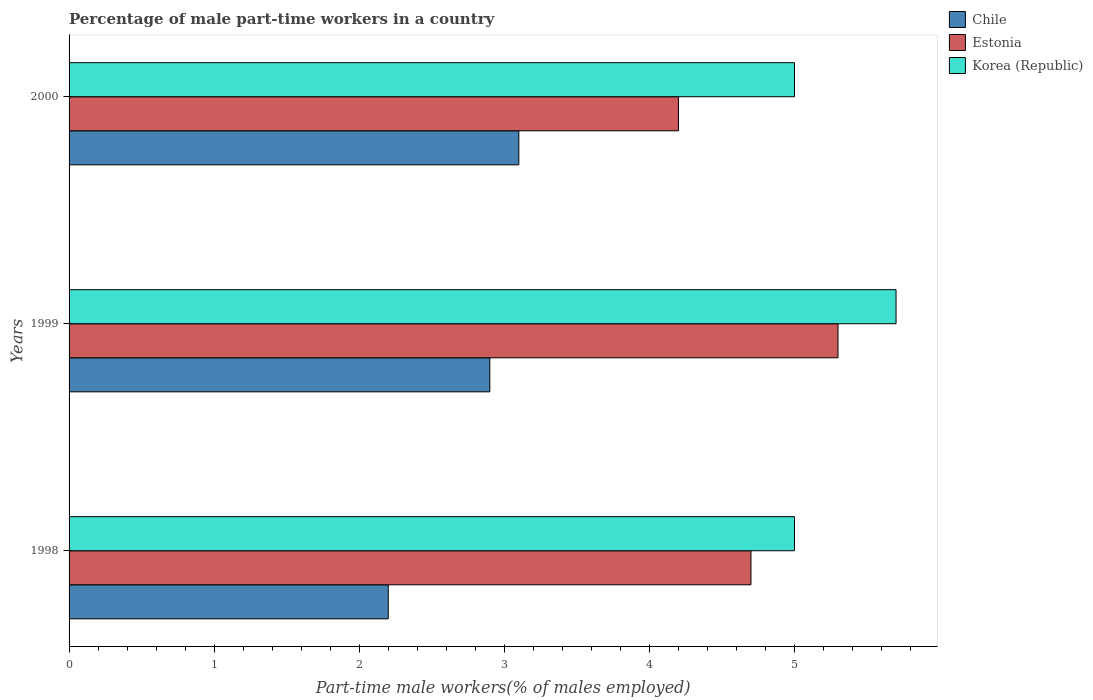Are the number of bars per tick equal to the number of legend labels?
Provide a short and direct response. Yes. Are the number of bars on each tick of the Y-axis equal?
Offer a terse response. Yes. What is the label of the 1st group of bars from the top?
Provide a short and direct response. 2000. What is the percentage of male part-time workers in Estonia in 1999?
Make the answer very short. 5.3. Across all years, what is the maximum percentage of male part-time workers in Chile?
Provide a short and direct response. 3.1. In which year was the percentage of male part-time workers in Estonia maximum?
Provide a succinct answer. 1999. What is the total percentage of male part-time workers in Estonia in the graph?
Keep it short and to the point. 14.2. What is the difference between the percentage of male part-time workers in Estonia in 2000 and the percentage of male part-time workers in Korea (Republic) in 1999?
Your answer should be very brief. -1.5. What is the average percentage of male part-time workers in Estonia per year?
Provide a succinct answer. 4.73. In the year 1998, what is the difference between the percentage of male part-time workers in Estonia and percentage of male part-time workers in Korea (Republic)?
Your answer should be compact. -0.3. What is the ratio of the percentage of male part-time workers in Chile in 1998 to that in 1999?
Provide a short and direct response. 0.76. Is the difference between the percentage of male part-time workers in Estonia in 1998 and 1999 greater than the difference between the percentage of male part-time workers in Korea (Republic) in 1998 and 1999?
Provide a short and direct response. Yes. What is the difference between the highest and the second highest percentage of male part-time workers in Estonia?
Ensure brevity in your answer.  0.6. What is the difference between the highest and the lowest percentage of male part-time workers in Korea (Republic)?
Ensure brevity in your answer.  0.7. In how many years, is the percentage of male part-time workers in Korea (Republic) greater than the average percentage of male part-time workers in Korea (Republic) taken over all years?
Give a very brief answer. 1. Is the sum of the percentage of male part-time workers in Estonia in 1999 and 2000 greater than the maximum percentage of male part-time workers in Korea (Republic) across all years?
Provide a succinct answer. Yes. What does the 2nd bar from the top in 1998 represents?
Offer a terse response. Estonia. What does the 2nd bar from the bottom in 1998 represents?
Ensure brevity in your answer.  Estonia. Is it the case that in every year, the sum of the percentage of male part-time workers in Korea (Republic) and percentage of male part-time workers in Estonia is greater than the percentage of male part-time workers in Chile?
Your answer should be very brief. Yes. How many bars are there?
Give a very brief answer. 9. What is the difference between two consecutive major ticks on the X-axis?
Your answer should be compact. 1. Are the values on the major ticks of X-axis written in scientific E-notation?
Provide a succinct answer. No. Does the graph contain grids?
Offer a very short reply. No. Where does the legend appear in the graph?
Your answer should be compact. Top right. How are the legend labels stacked?
Give a very brief answer. Vertical. What is the title of the graph?
Give a very brief answer. Percentage of male part-time workers in a country. Does "Oman" appear as one of the legend labels in the graph?
Offer a very short reply. No. What is the label or title of the X-axis?
Provide a succinct answer. Part-time male workers(% of males employed). What is the label or title of the Y-axis?
Your answer should be compact. Years. What is the Part-time male workers(% of males employed) in Chile in 1998?
Your answer should be compact. 2.2. What is the Part-time male workers(% of males employed) of Estonia in 1998?
Keep it short and to the point. 4.7. What is the Part-time male workers(% of males employed) of Korea (Republic) in 1998?
Offer a very short reply. 5. What is the Part-time male workers(% of males employed) of Chile in 1999?
Keep it short and to the point. 2.9. What is the Part-time male workers(% of males employed) of Estonia in 1999?
Your response must be concise. 5.3. What is the Part-time male workers(% of males employed) in Korea (Republic) in 1999?
Provide a succinct answer. 5.7. What is the Part-time male workers(% of males employed) in Chile in 2000?
Make the answer very short. 3.1. What is the Part-time male workers(% of males employed) of Estonia in 2000?
Offer a terse response. 4.2. What is the Part-time male workers(% of males employed) of Korea (Republic) in 2000?
Provide a succinct answer. 5. Across all years, what is the maximum Part-time male workers(% of males employed) in Chile?
Make the answer very short. 3.1. Across all years, what is the maximum Part-time male workers(% of males employed) in Estonia?
Your answer should be very brief. 5.3. Across all years, what is the maximum Part-time male workers(% of males employed) in Korea (Republic)?
Ensure brevity in your answer.  5.7. Across all years, what is the minimum Part-time male workers(% of males employed) of Chile?
Your response must be concise. 2.2. Across all years, what is the minimum Part-time male workers(% of males employed) in Estonia?
Ensure brevity in your answer.  4.2. Across all years, what is the minimum Part-time male workers(% of males employed) of Korea (Republic)?
Make the answer very short. 5. What is the difference between the Part-time male workers(% of males employed) of Korea (Republic) in 1998 and that in 1999?
Your answer should be compact. -0.7. What is the difference between the Part-time male workers(% of males employed) of Chile in 1998 and that in 2000?
Your answer should be very brief. -0.9. What is the difference between the Part-time male workers(% of males employed) of Estonia in 1998 and that in 2000?
Keep it short and to the point. 0.5. What is the difference between the Part-time male workers(% of males employed) in Korea (Republic) in 1998 and that in 2000?
Your response must be concise. 0. What is the difference between the Part-time male workers(% of males employed) in Estonia in 1999 and that in 2000?
Provide a short and direct response. 1.1. What is the difference between the Part-time male workers(% of males employed) in Korea (Republic) in 1999 and that in 2000?
Your answer should be very brief. 0.7. What is the difference between the Part-time male workers(% of males employed) in Chile in 1998 and the Part-time male workers(% of males employed) in Korea (Republic) in 1999?
Keep it short and to the point. -3.5. What is the difference between the Part-time male workers(% of males employed) of Chile in 1999 and the Part-time male workers(% of males employed) of Estonia in 2000?
Provide a succinct answer. -1.3. What is the difference between the Part-time male workers(% of males employed) of Chile in 1999 and the Part-time male workers(% of males employed) of Korea (Republic) in 2000?
Offer a very short reply. -2.1. What is the average Part-time male workers(% of males employed) in Chile per year?
Keep it short and to the point. 2.73. What is the average Part-time male workers(% of males employed) of Estonia per year?
Offer a very short reply. 4.73. What is the average Part-time male workers(% of males employed) of Korea (Republic) per year?
Keep it short and to the point. 5.23. In the year 1998, what is the difference between the Part-time male workers(% of males employed) in Chile and Part-time male workers(% of males employed) in Estonia?
Your answer should be compact. -2.5. In the year 1998, what is the difference between the Part-time male workers(% of males employed) of Chile and Part-time male workers(% of males employed) of Korea (Republic)?
Offer a terse response. -2.8. In the year 1998, what is the difference between the Part-time male workers(% of males employed) in Estonia and Part-time male workers(% of males employed) in Korea (Republic)?
Offer a very short reply. -0.3. In the year 1999, what is the difference between the Part-time male workers(% of males employed) in Chile and Part-time male workers(% of males employed) in Korea (Republic)?
Provide a succinct answer. -2.8. In the year 2000, what is the difference between the Part-time male workers(% of males employed) in Chile and Part-time male workers(% of males employed) in Estonia?
Your answer should be very brief. -1.1. In the year 2000, what is the difference between the Part-time male workers(% of males employed) in Chile and Part-time male workers(% of males employed) in Korea (Republic)?
Make the answer very short. -1.9. What is the ratio of the Part-time male workers(% of males employed) of Chile in 1998 to that in 1999?
Provide a succinct answer. 0.76. What is the ratio of the Part-time male workers(% of males employed) of Estonia in 1998 to that in 1999?
Provide a succinct answer. 0.89. What is the ratio of the Part-time male workers(% of males employed) of Korea (Republic) in 1998 to that in 1999?
Provide a short and direct response. 0.88. What is the ratio of the Part-time male workers(% of males employed) in Chile in 1998 to that in 2000?
Your answer should be compact. 0.71. What is the ratio of the Part-time male workers(% of males employed) in Estonia in 1998 to that in 2000?
Your response must be concise. 1.12. What is the ratio of the Part-time male workers(% of males employed) in Chile in 1999 to that in 2000?
Give a very brief answer. 0.94. What is the ratio of the Part-time male workers(% of males employed) in Estonia in 1999 to that in 2000?
Your answer should be very brief. 1.26. What is the ratio of the Part-time male workers(% of males employed) in Korea (Republic) in 1999 to that in 2000?
Give a very brief answer. 1.14. What is the difference between the highest and the second highest Part-time male workers(% of males employed) of Chile?
Offer a very short reply. 0.2. What is the difference between the highest and the second highest Part-time male workers(% of males employed) in Estonia?
Offer a terse response. 0.6. What is the difference between the highest and the lowest Part-time male workers(% of males employed) of Chile?
Give a very brief answer. 0.9. 